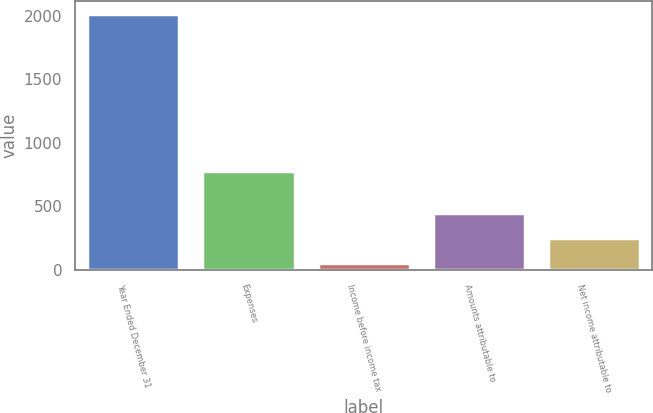Convert chart to OTSL. <chart><loc_0><loc_0><loc_500><loc_500><bar_chart><fcel>Year Ended December 31<fcel>Expenses<fcel>Income before income tax<fcel>Amounts attributable to<fcel>Net income attributable to<nl><fcel>2013<fcel>776<fcel>56<fcel>447.4<fcel>251.7<nl></chart> 